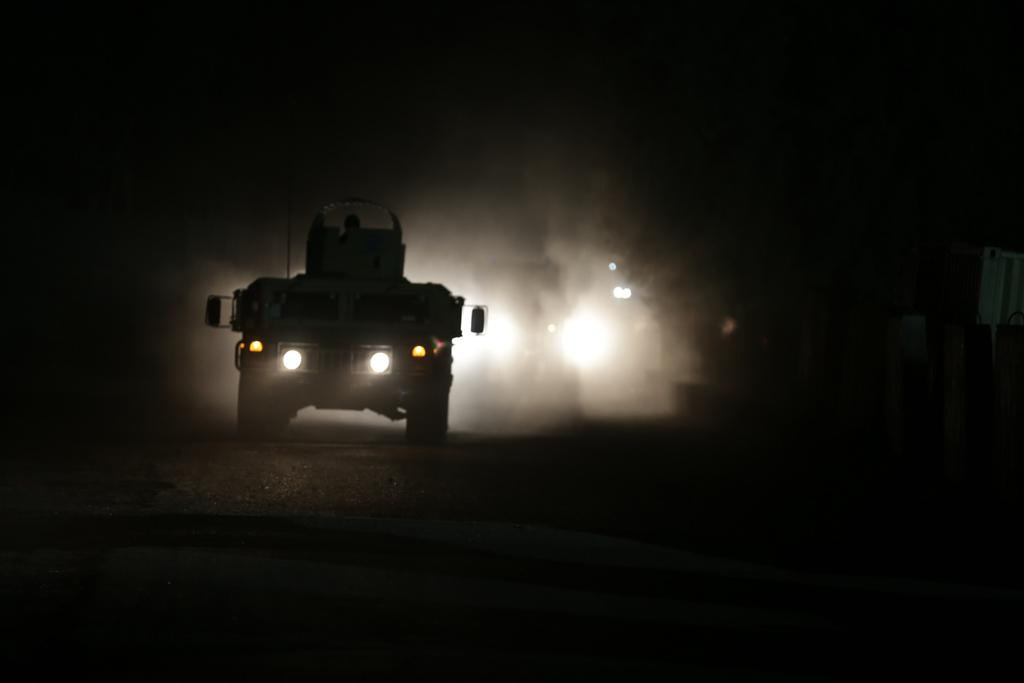What is the main subject of the image? There is a vehicle in the image. Where is the vehicle located? The vehicle is on the road. What feature does the vehicle have? The vehicle has flashing lights. What can be inferred about the time of day or lighting conditions in the image? The scene is set in the dark. What type of representative is standing next to the vehicle in the image? There is no representative present in the image; it only features a vehicle on the road with flashing lights. Can you read the letter that is being delivered by the vehicle in the image? There is no letter being delivered by the vehicle in the image. 